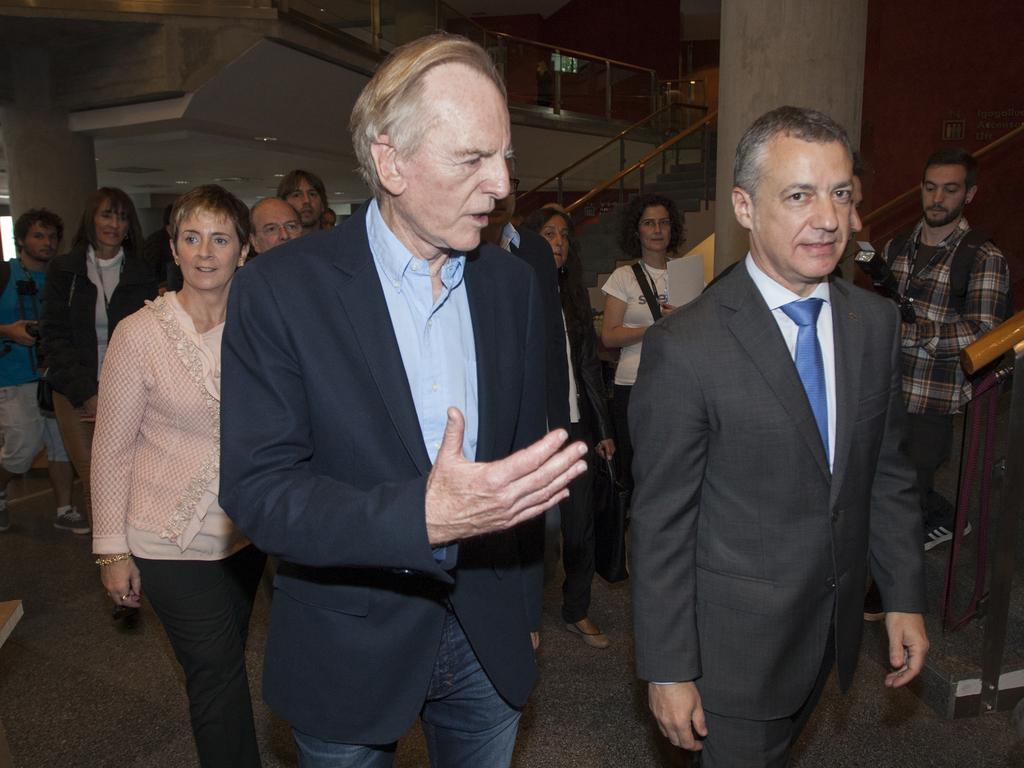How would you summarize this image in a sentence or two? In this image we can see few people standing on the floor and there are stairs, railing and pillars. 